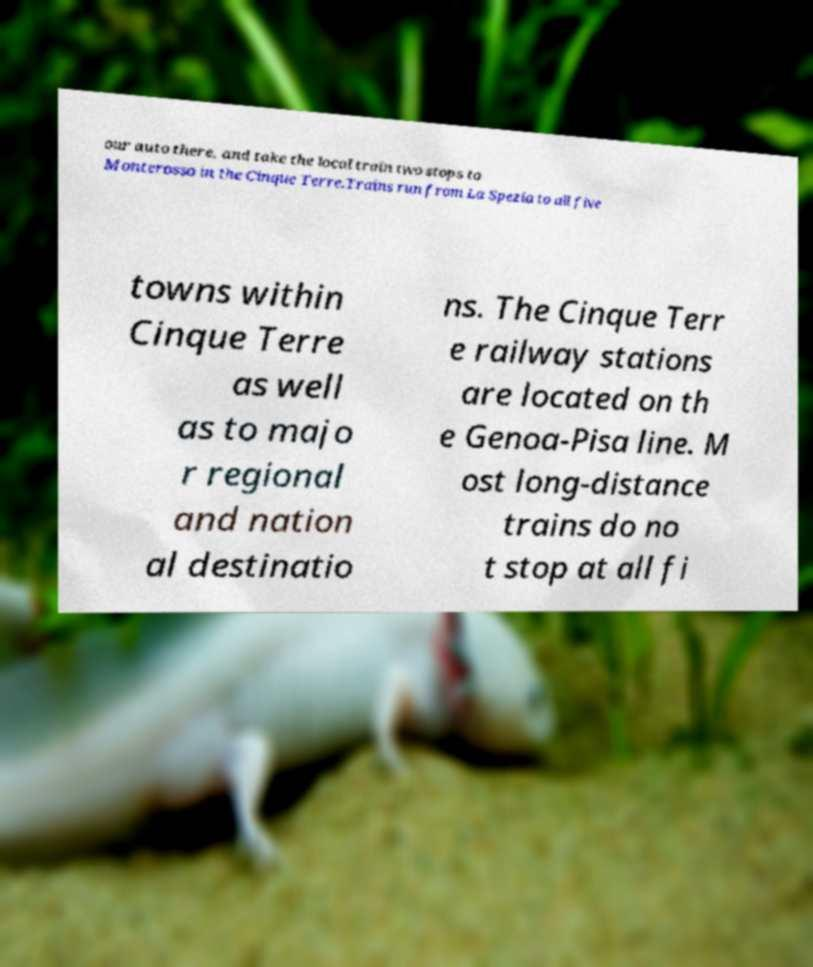Can you read and provide the text displayed in the image?This photo seems to have some interesting text. Can you extract and type it out for me? our auto there, and take the local train two stops to Monterosso in the Cinque Terre.Trains run from La Spezia to all five towns within Cinque Terre as well as to majo r regional and nation al destinatio ns. The Cinque Terr e railway stations are located on th e Genoa-Pisa line. M ost long-distance trains do no t stop at all fi 